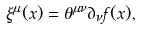<formula> <loc_0><loc_0><loc_500><loc_500>\xi ^ { \mu } ( x ) = \theta ^ { \mu \nu } \partial _ { \nu } f ( x ) ,</formula> 